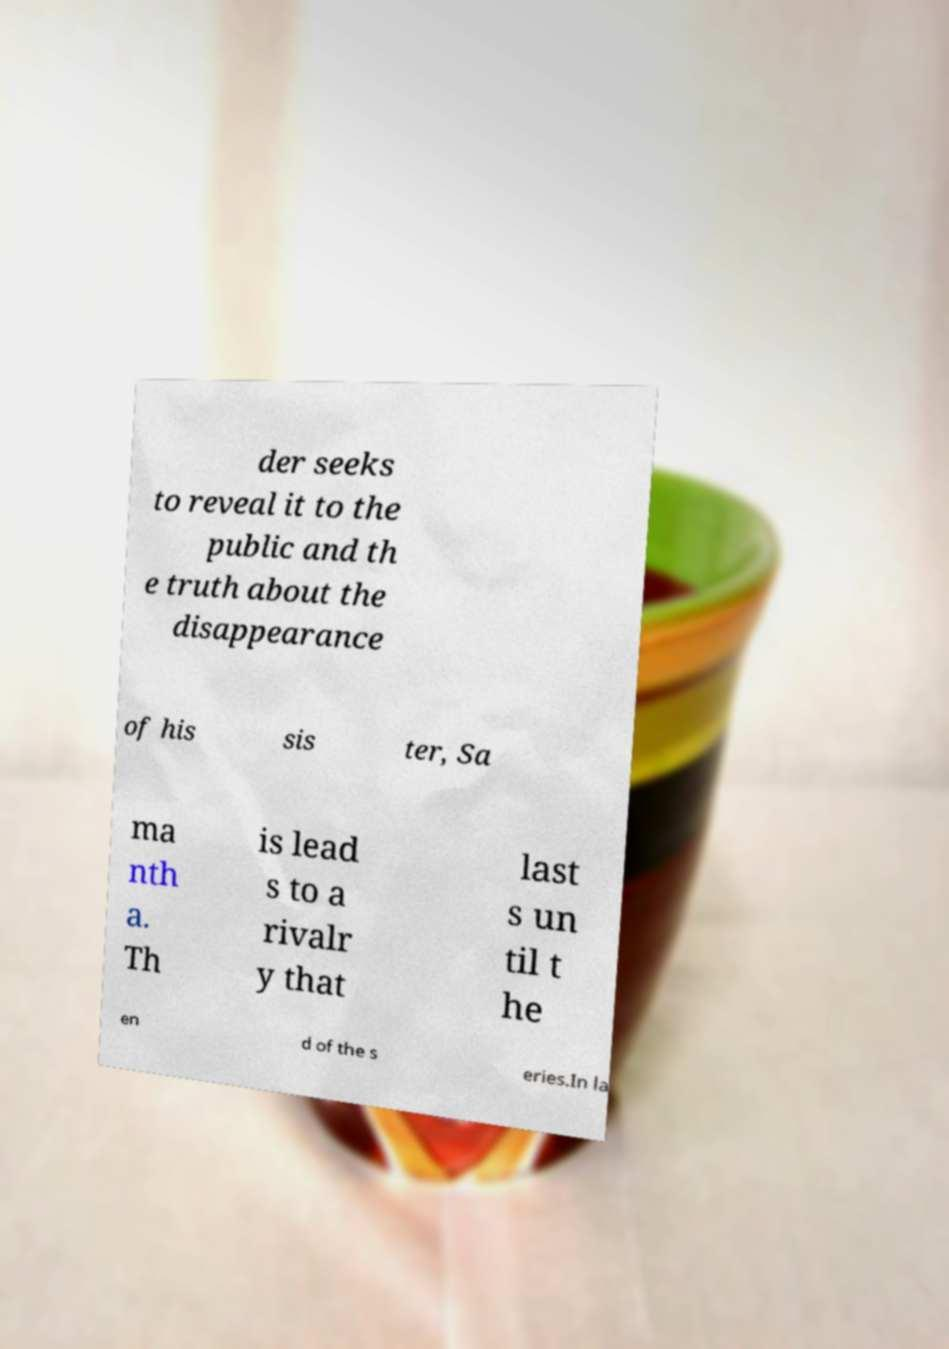For documentation purposes, I need the text within this image transcribed. Could you provide that? der seeks to reveal it to the public and th e truth about the disappearance of his sis ter, Sa ma nth a. Th is lead s to a rivalr y that last s un til t he en d of the s eries.In la 